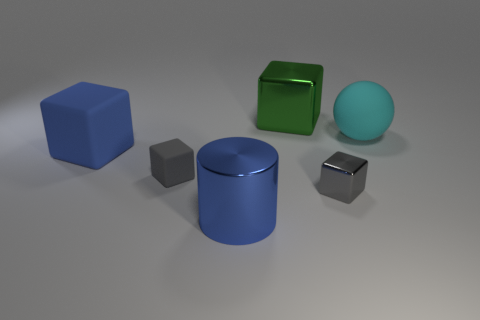Subtract all yellow blocks. Subtract all cyan balls. How many blocks are left? 4 Add 2 gray metallic objects. How many objects exist? 8 Subtract all spheres. How many objects are left? 5 Add 2 big green shiny things. How many big green shiny things exist? 3 Subtract 2 gray cubes. How many objects are left? 4 Subtract all large blue metal cylinders. Subtract all tiny gray metallic cubes. How many objects are left? 4 Add 2 matte cubes. How many matte cubes are left? 4 